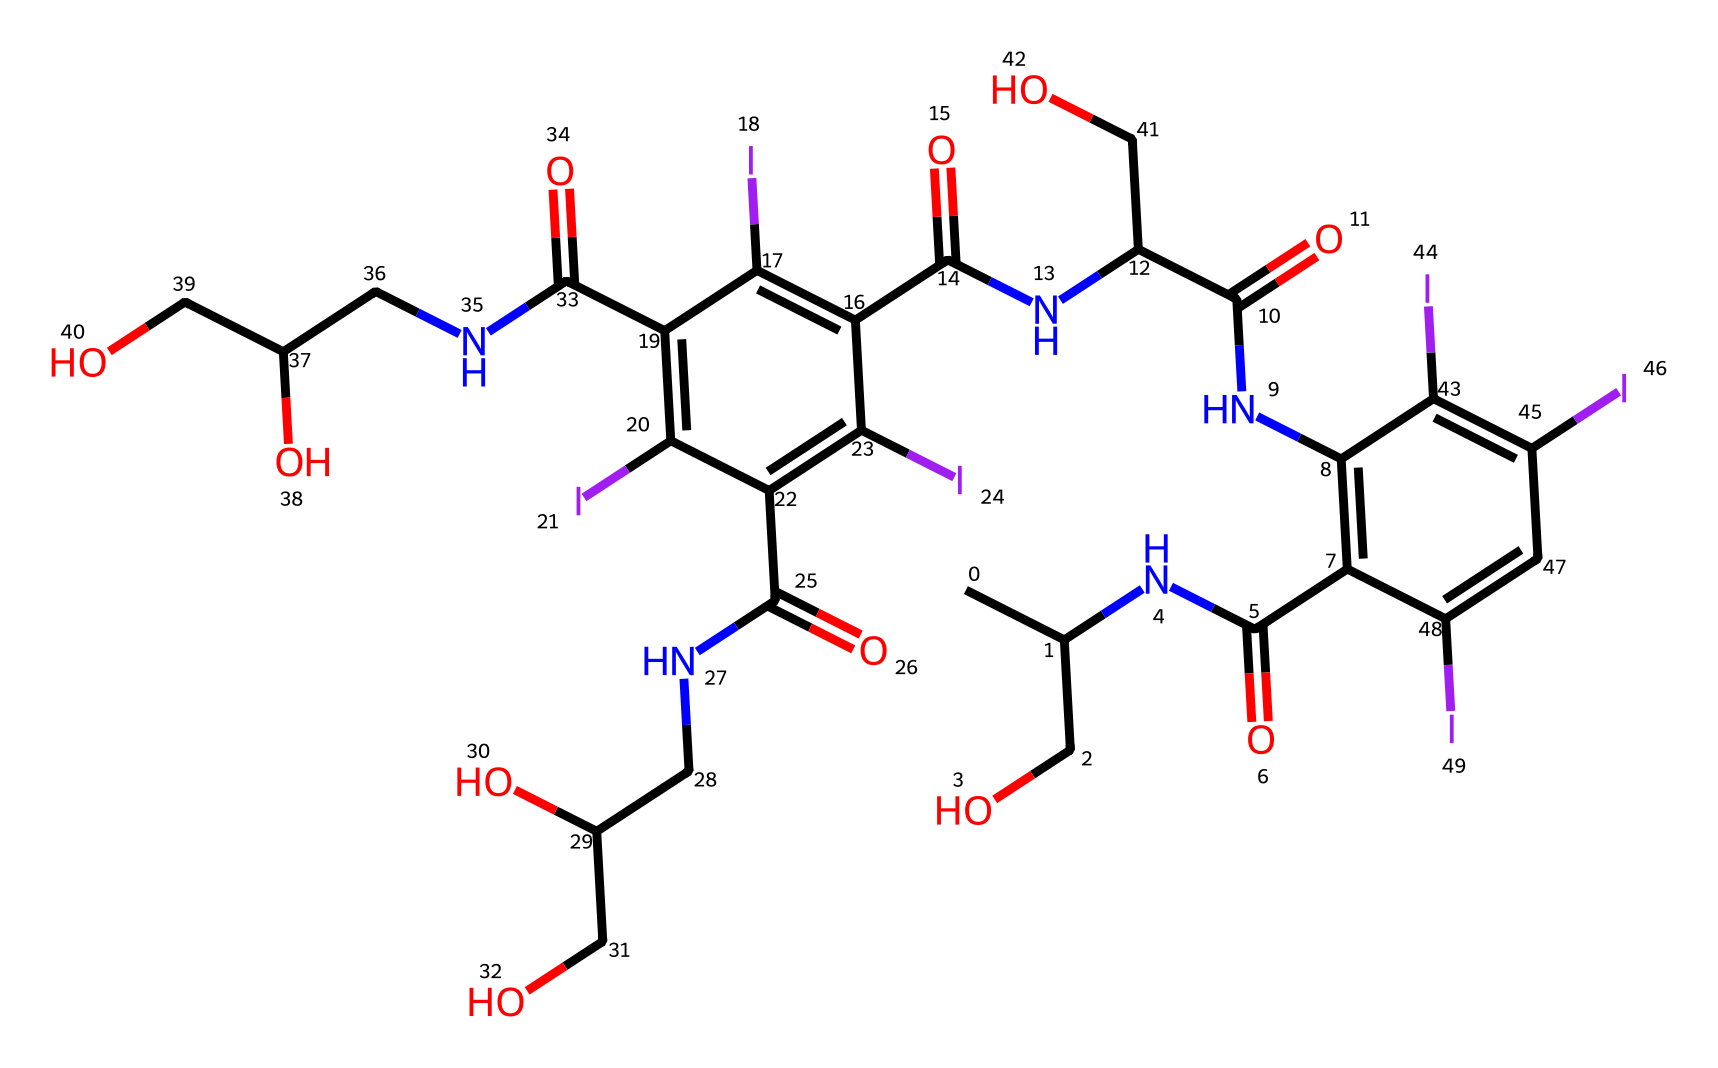What is the molecular formula of this iodine-based contrast agent? To find the molecular formula, we need to identify the number of each type of atom in the structure represented by the SMILES. Scanning the SMILES, we find several carbon (C), hydrogen (H), nitrogen (N), oxygen (O), and iodine (I) atoms. Counting them yields: C: 24, H: 34, N: 6, O: 6, and I: 6. Thus, the molecular formula is C24H34N6O6I6.
Answer: C24H34N6O6I6 How many iodine atoms are present in this chemical structure? The number of iodine atoms can be counted directly from the SMILES notation. For this structure, we can see there are six instances of "I" indicating the presence of iodine atoms.
Answer: 6 What type of functional groups are present in this molecule? Functional groups are specific groups of atoms that influence the chemical properties of compounds. In the SMILES, we can identify amides (C(=O)N), hydroxyl groups (–OH), and several aromatic functional groups characterized by alternating double bonds.
Answer: amides, hydroxyls, aromatic Which component contributes to the hydrophilicity of this iodine-based contrast agent? Hydrophilicity typically arises from the presence of polar functional groups. In the chemical structure, the hydroxyl groups (–OH) and the amide groups (C(=O)N) are polar and contribute to the molecule's interaction with water, enhancing its solubility.
Answer: hydroxyl and amide groups What role do the iodine atoms play in the chemical? Iodine atoms are heavy and provide excellent contrast in imaging due to X-ray absorption properties, making them essential for neuroimaging applications. The presence of iodine enhances the visibility of vascular structures in imaging.
Answer: X-ray contrast agent How many rings are present in the structure? To determine the number of rings, we need to look for cyclic structures indicated by the SMILES notation. In this SMILES, there are two instances of "C1" and "C2" indicating two separate ring structures. Thus, there are two rings in the entire structure.
Answer: 2 What type of bonds are predominantly present in this compound? In assessing the bonding, we look for the types of bonds between atoms in the SMILES representation. This structure predominantly features carbon-carbon (C-C) and carbon-oxygen (C-O) single or double bonds, along with carbon-nitrogen (C-N) and carbon-iodine (C-I) single bonds as well.
Answer: single and double bonds 